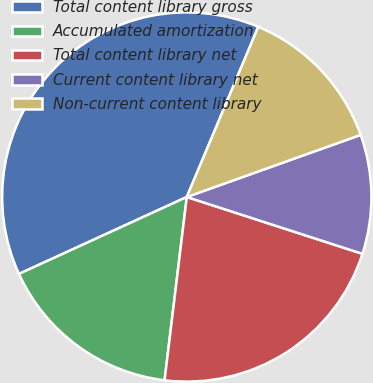Convert chart. <chart><loc_0><loc_0><loc_500><loc_500><pie_chart><fcel>Total content library gross<fcel>Accumulated amortization<fcel>Total content library net<fcel>Current content library net<fcel>Non-current content library<nl><fcel>38.17%<fcel>16.24%<fcel>21.94%<fcel>10.44%<fcel>13.21%<nl></chart> 